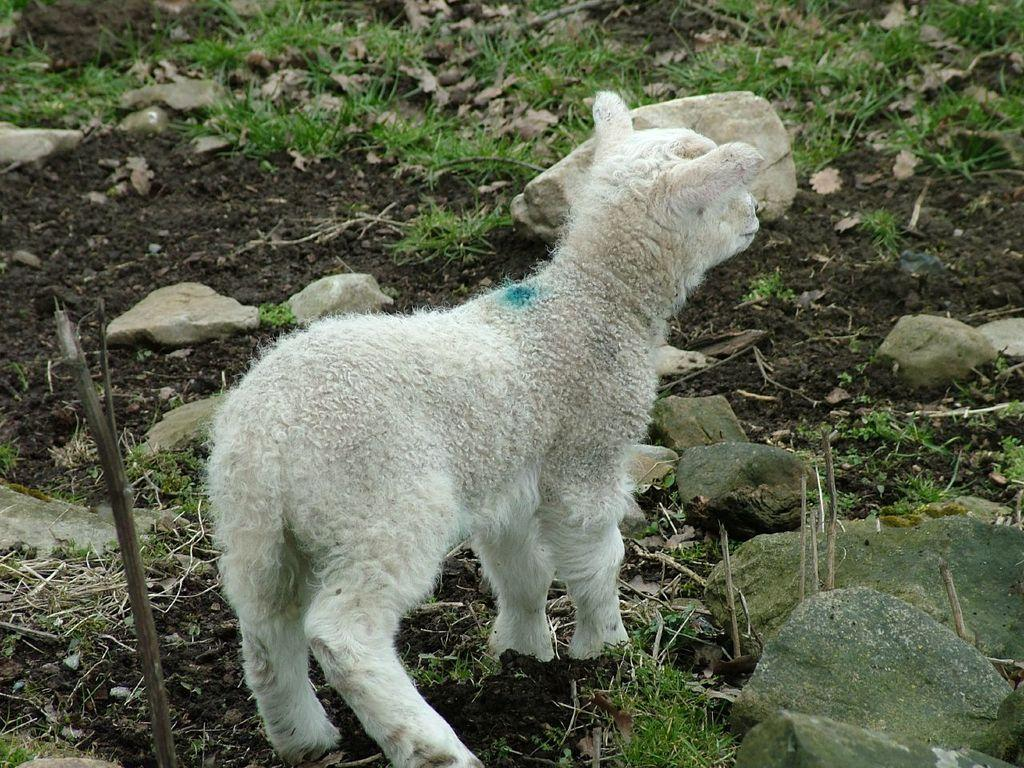What type of animal is in the image? There is an animal in the image, but the specific type cannot be determined from the provided facts. What type of vegetation is in the image? There is grass in the image. What type of inanimate objects are in the image? There are stones in the image. What word is the animal expert saying in the image? There is no indication in the image that an animal expert is present or speaking, so it is not possible to determine what word they might be saying. 